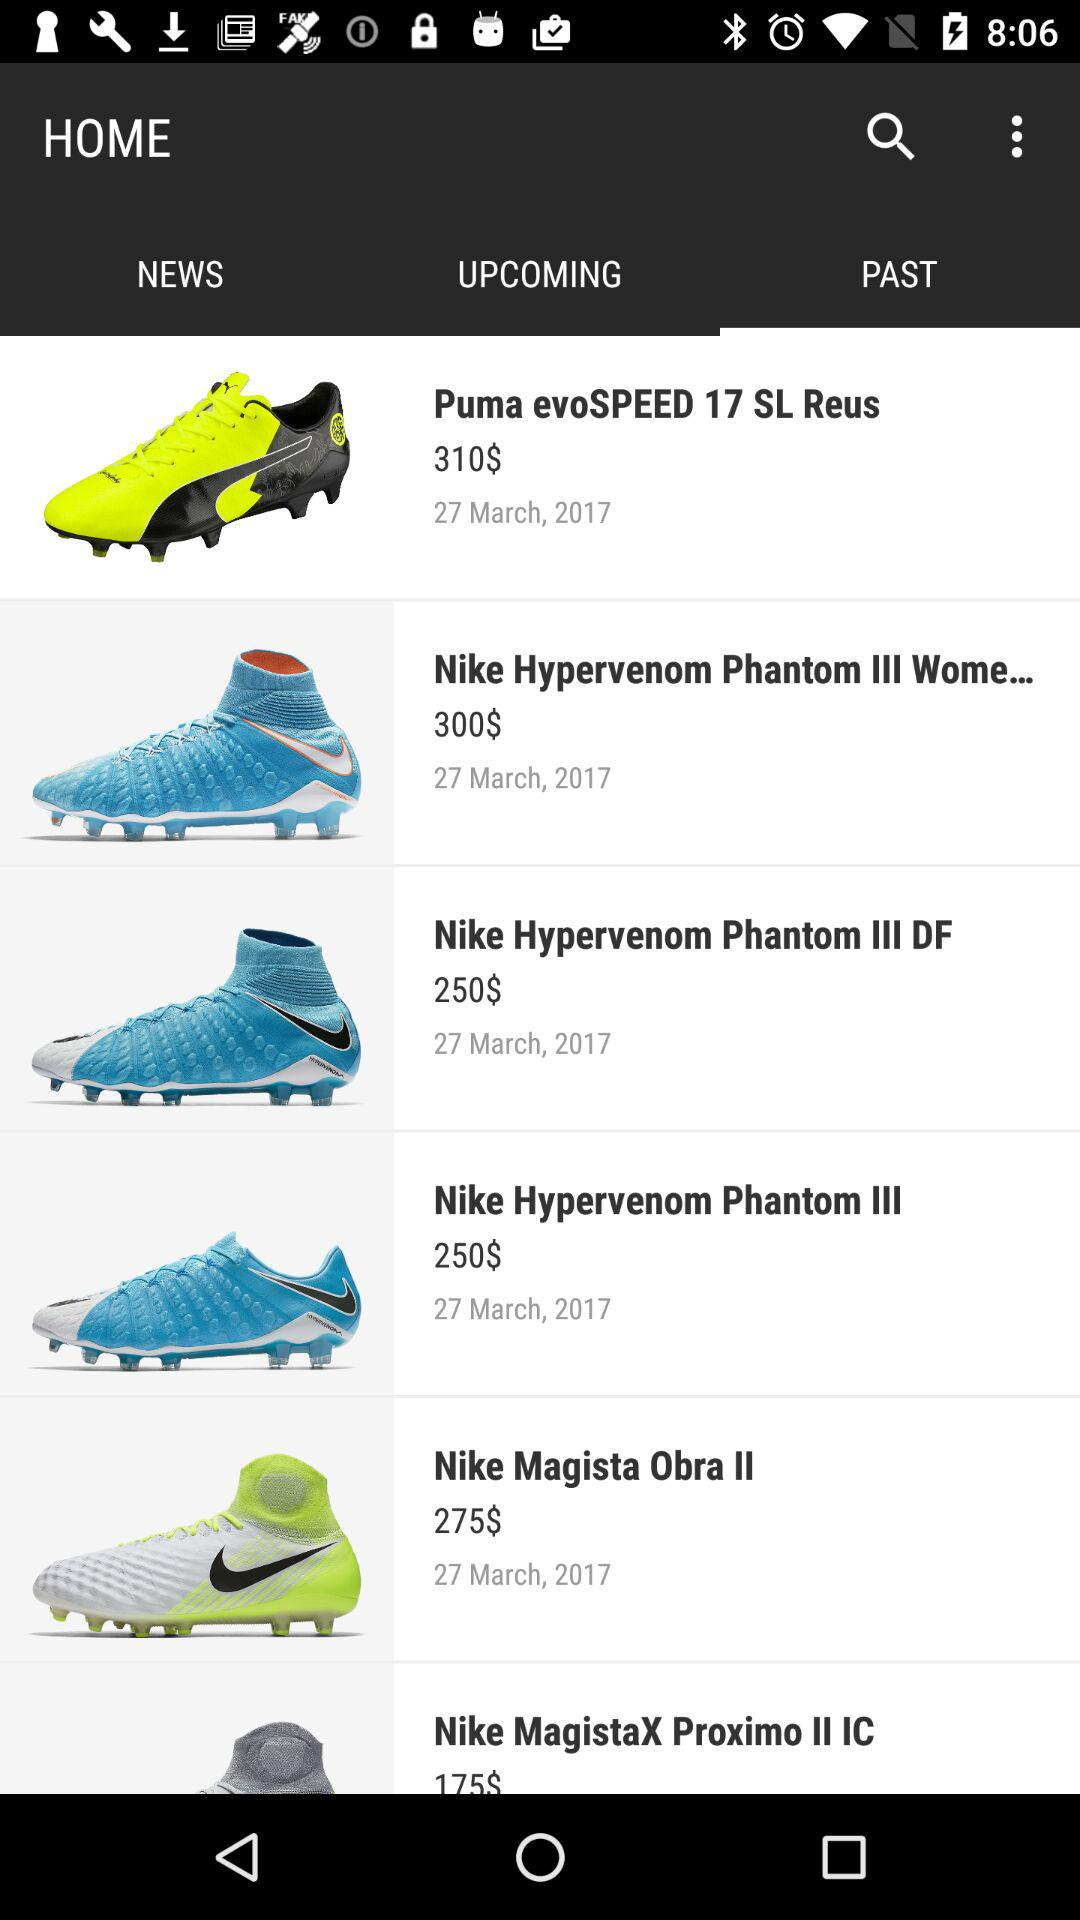Which item has a price of 310 dollars? The item is "Puma evoSPEED 17 SL Reus". 